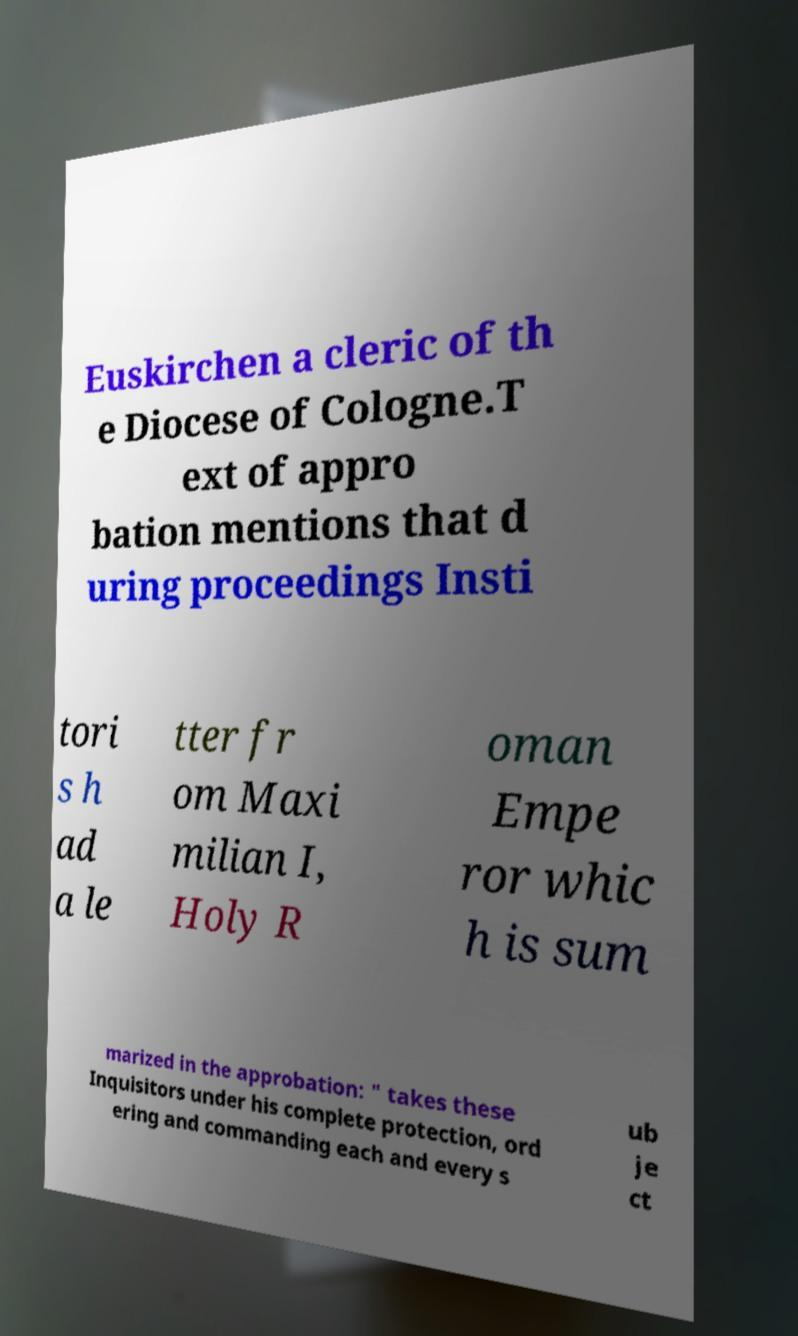For documentation purposes, I need the text within this image transcribed. Could you provide that? Euskirchen a cleric of th e Diocese of Cologne.T ext of appro bation mentions that d uring proceedings Insti tori s h ad a le tter fr om Maxi milian I, Holy R oman Empe ror whic h is sum marized in the approbation: " takes these Inquisitors under his complete protection, ord ering and commanding each and every s ub je ct 